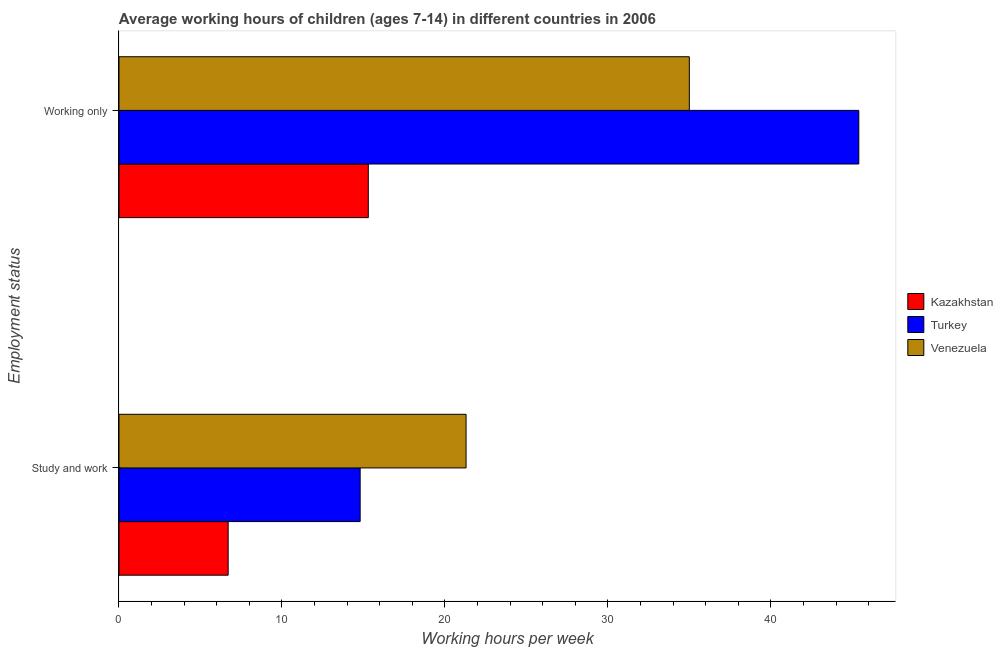Are the number of bars per tick equal to the number of legend labels?
Your answer should be very brief. Yes. Are the number of bars on each tick of the Y-axis equal?
Ensure brevity in your answer.  Yes. What is the label of the 1st group of bars from the top?
Give a very brief answer. Working only. Across all countries, what is the maximum average working hour of children involved in only work?
Your answer should be very brief. 45.4. In which country was the average working hour of children involved in study and work maximum?
Make the answer very short. Venezuela. In which country was the average working hour of children involved in only work minimum?
Make the answer very short. Kazakhstan. What is the total average working hour of children involved in only work in the graph?
Your answer should be compact. 95.7. What is the difference between the average working hour of children involved in only work in Kazakhstan and that in Turkey?
Your answer should be compact. -30.1. What is the difference between the average working hour of children involved in study and work in Kazakhstan and the average working hour of children involved in only work in Venezuela?
Make the answer very short. -28.3. What is the average average working hour of children involved in only work per country?
Ensure brevity in your answer.  31.9. What is the difference between the average working hour of children involved in only work and average working hour of children involved in study and work in Turkey?
Your response must be concise. 30.6. What is the ratio of the average working hour of children involved in only work in Kazakhstan to that in Turkey?
Offer a very short reply. 0.34. Is the average working hour of children involved in only work in Kazakhstan less than that in Venezuela?
Your answer should be compact. Yes. In how many countries, is the average working hour of children involved in only work greater than the average average working hour of children involved in only work taken over all countries?
Offer a very short reply. 2. What does the 2nd bar from the top in Study and work represents?
Your response must be concise. Turkey. What does the 1st bar from the bottom in Working only represents?
Your answer should be compact. Kazakhstan. Are all the bars in the graph horizontal?
Your answer should be compact. Yes. How many countries are there in the graph?
Your answer should be very brief. 3. How many legend labels are there?
Keep it short and to the point. 3. What is the title of the graph?
Offer a very short reply. Average working hours of children (ages 7-14) in different countries in 2006. Does "United States" appear as one of the legend labels in the graph?
Offer a terse response. No. What is the label or title of the X-axis?
Your response must be concise. Working hours per week. What is the label or title of the Y-axis?
Keep it short and to the point. Employment status. What is the Working hours per week of Kazakhstan in Study and work?
Ensure brevity in your answer.  6.7. What is the Working hours per week in Venezuela in Study and work?
Keep it short and to the point. 21.3. What is the Working hours per week in Turkey in Working only?
Make the answer very short. 45.4. Across all Employment status, what is the maximum Working hours per week of Turkey?
Offer a very short reply. 45.4. Across all Employment status, what is the maximum Working hours per week of Venezuela?
Offer a terse response. 35. Across all Employment status, what is the minimum Working hours per week in Kazakhstan?
Ensure brevity in your answer.  6.7. Across all Employment status, what is the minimum Working hours per week in Venezuela?
Provide a short and direct response. 21.3. What is the total Working hours per week in Kazakhstan in the graph?
Your answer should be very brief. 22. What is the total Working hours per week in Turkey in the graph?
Ensure brevity in your answer.  60.2. What is the total Working hours per week of Venezuela in the graph?
Your response must be concise. 56.3. What is the difference between the Working hours per week of Turkey in Study and work and that in Working only?
Your response must be concise. -30.6. What is the difference between the Working hours per week in Venezuela in Study and work and that in Working only?
Your answer should be compact. -13.7. What is the difference between the Working hours per week in Kazakhstan in Study and work and the Working hours per week in Turkey in Working only?
Your response must be concise. -38.7. What is the difference between the Working hours per week of Kazakhstan in Study and work and the Working hours per week of Venezuela in Working only?
Provide a short and direct response. -28.3. What is the difference between the Working hours per week of Turkey in Study and work and the Working hours per week of Venezuela in Working only?
Provide a short and direct response. -20.2. What is the average Working hours per week of Turkey per Employment status?
Your answer should be very brief. 30.1. What is the average Working hours per week of Venezuela per Employment status?
Offer a terse response. 28.15. What is the difference between the Working hours per week of Kazakhstan and Working hours per week of Turkey in Study and work?
Keep it short and to the point. -8.1. What is the difference between the Working hours per week of Kazakhstan and Working hours per week of Venezuela in Study and work?
Keep it short and to the point. -14.6. What is the difference between the Working hours per week in Turkey and Working hours per week in Venezuela in Study and work?
Ensure brevity in your answer.  -6.5. What is the difference between the Working hours per week of Kazakhstan and Working hours per week of Turkey in Working only?
Provide a short and direct response. -30.1. What is the difference between the Working hours per week in Kazakhstan and Working hours per week in Venezuela in Working only?
Provide a succinct answer. -19.7. What is the difference between the Working hours per week of Turkey and Working hours per week of Venezuela in Working only?
Provide a short and direct response. 10.4. What is the ratio of the Working hours per week in Kazakhstan in Study and work to that in Working only?
Ensure brevity in your answer.  0.44. What is the ratio of the Working hours per week in Turkey in Study and work to that in Working only?
Provide a short and direct response. 0.33. What is the ratio of the Working hours per week in Venezuela in Study and work to that in Working only?
Offer a very short reply. 0.61. What is the difference between the highest and the second highest Working hours per week of Turkey?
Ensure brevity in your answer.  30.6. What is the difference between the highest and the second highest Working hours per week in Venezuela?
Offer a terse response. 13.7. What is the difference between the highest and the lowest Working hours per week of Kazakhstan?
Provide a short and direct response. 8.6. What is the difference between the highest and the lowest Working hours per week of Turkey?
Your response must be concise. 30.6. What is the difference between the highest and the lowest Working hours per week of Venezuela?
Offer a terse response. 13.7. 